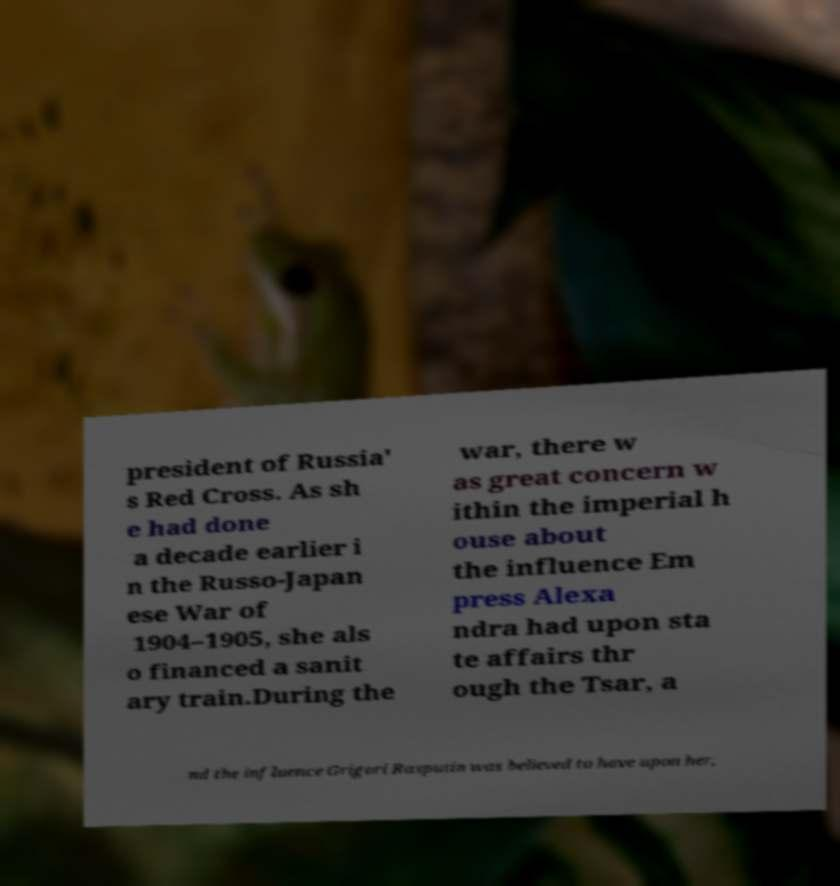I need the written content from this picture converted into text. Can you do that? president of Russia' s Red Cross. As sh e had done a decade earlier i n the Russo-Japan ese War of 1904–1905, she als o financed a sanit ary train.During the war, there w as great concern w ithin the imperial h ouse about the influence Em press Alexa ndra had upon sta te affairs thr ough the Tsar, a nd the influence Grigori Rasputin was believed to have upon her, 